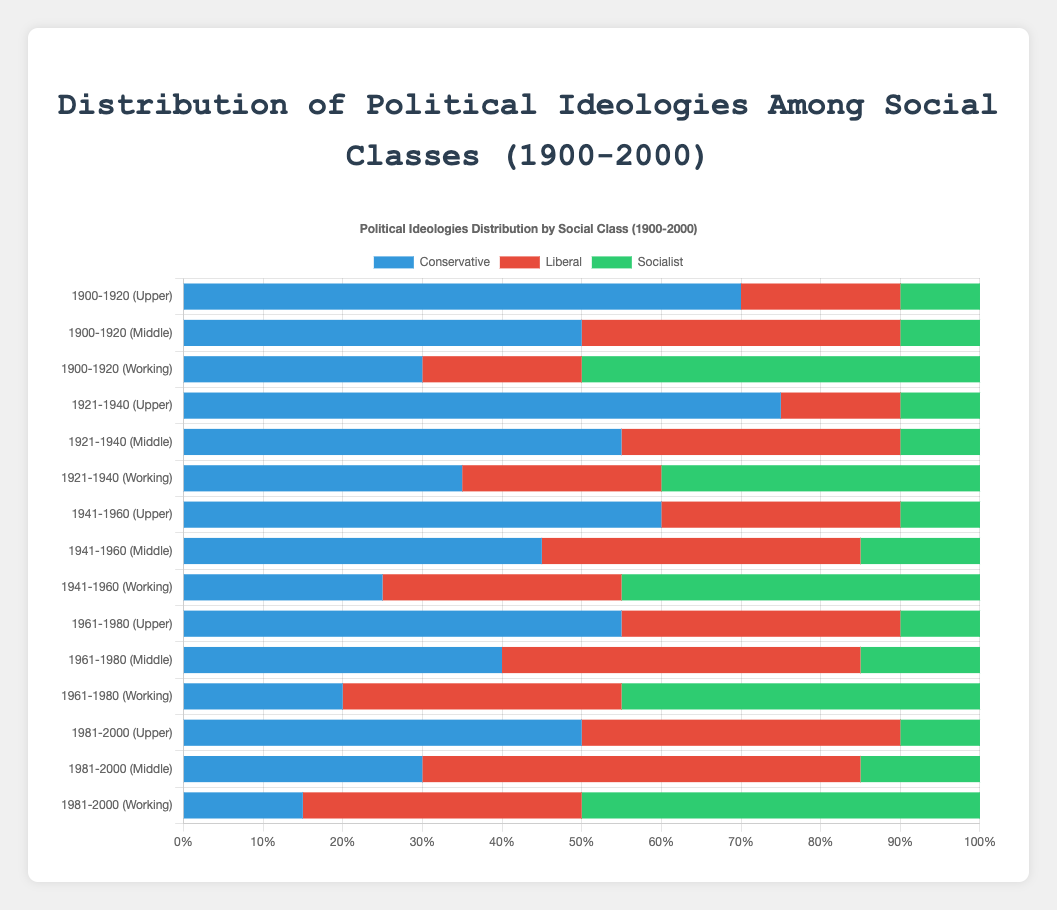What trend can you observe in the upper class's preference for conservatism from 1900 to 2000? The visual trend in the chart shows that the preference for conservatism in the upper class starts at 70% in 1900-1920, peaks at 75% in 1921-1940, and then gradually declines to 50% by 1981-2000. The bar corresponding to conservative ideology in the upper-class section visually decreases in length over time.
Answer: Declining trend Which social class had the highest percentage of socialist ideology in the 1921-1940 period? The bar representing the working class shows a 40% preference for socialist ideology during 1921-1940, which is the highest, compared to the upper class (10%) and middle class (10%).
Answer: Working class What is the total percentage of socialist ideology in the working class from 1900-1920 to 1981-2000? Sum the percentages of socialist ideology for the working class over each period: 50% + 40% + 45% + 45% + 50%. This equals 230%.
Answer: 230% In which period did the middle class have the highest preference for liberal ideology? Observing the visual length of the liberal bars for the middle class, the longest one corresponds to the period 1981-2000, indicating a preference of 55%, which is the highest among all periods.
Answer: 1981-2000 By how much did the conservative preference in the middle class decrease from 1921-1940 to 1981-2000? The preference for conservatism in the middle class declined from 55% in 1921-1940 to 30% in 1981-2000. The difference is 55% - 30% = 25%.
Answer: 25% How did the liberal preference in the working class change from 1900-1920 to 1981-2000? The liberal preference in the working class increased from 20% in 1900-1920 to 35% in 1981-2000. The visual height of the liberal bars for the working class shows an increasing trend.
Answer: Increased What was the average preference for conservative ideology across all social classes during 1961-1980? Calculate the average by adding the conservative percentages for all classes in 1961-1980 and dividing by the number of classes: (55% + 40% + 20%) / 3 = 38.33%.
Answer: 38.33% Which social class had the smallest change in conservative preference from 1941-1960 to 1961-1980? Compare the changes: upper class (60% to 55% = -5%), middle class (45% to 40% = -5%), working class (25% to 20% = -5%). All classes had an equal change of -5%.
Answer: All classes, equal change Which color represents socialist ideology in the chart? The green color in the chart corresponds to the socialist ideology across all social classes. This is evident from the green segments of the bars labeled "Socialist" in the legend.
Answer: Green 